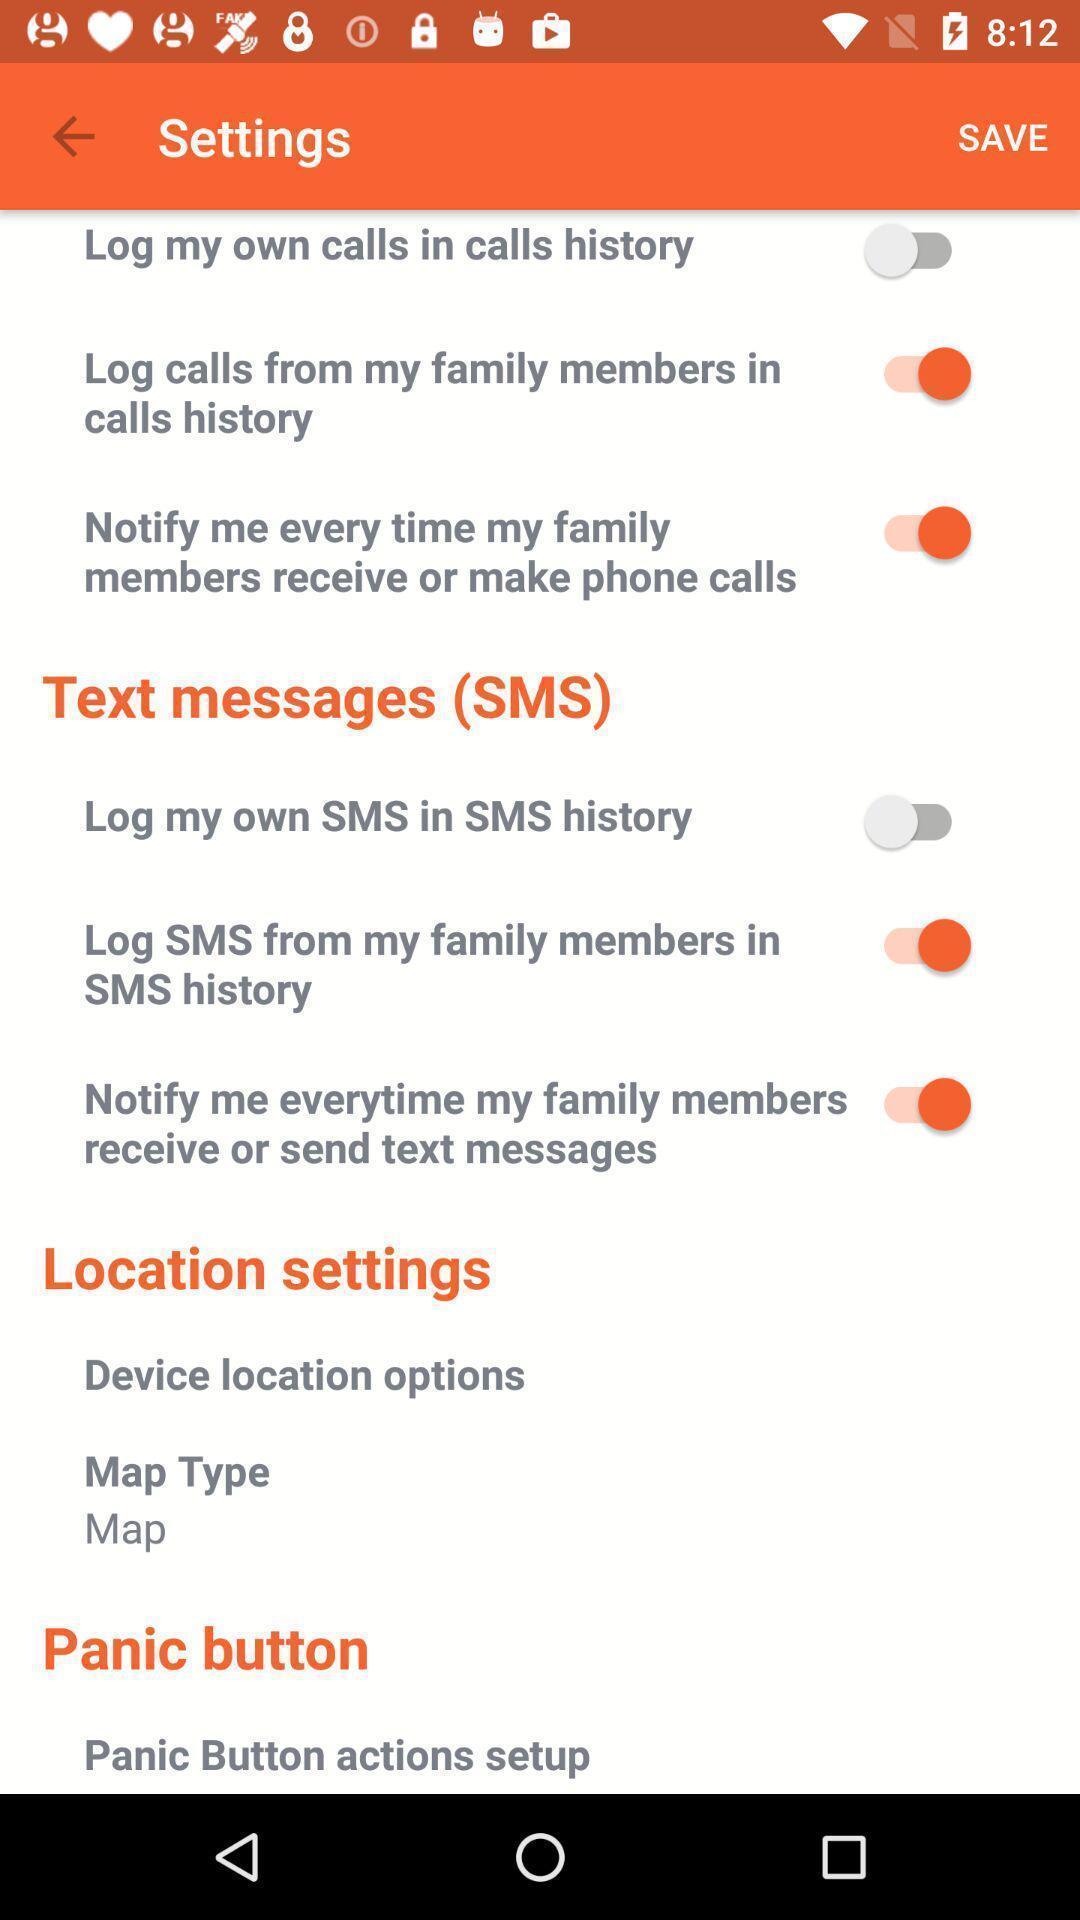Provide a description of this screenshot. Settings page with different options. 